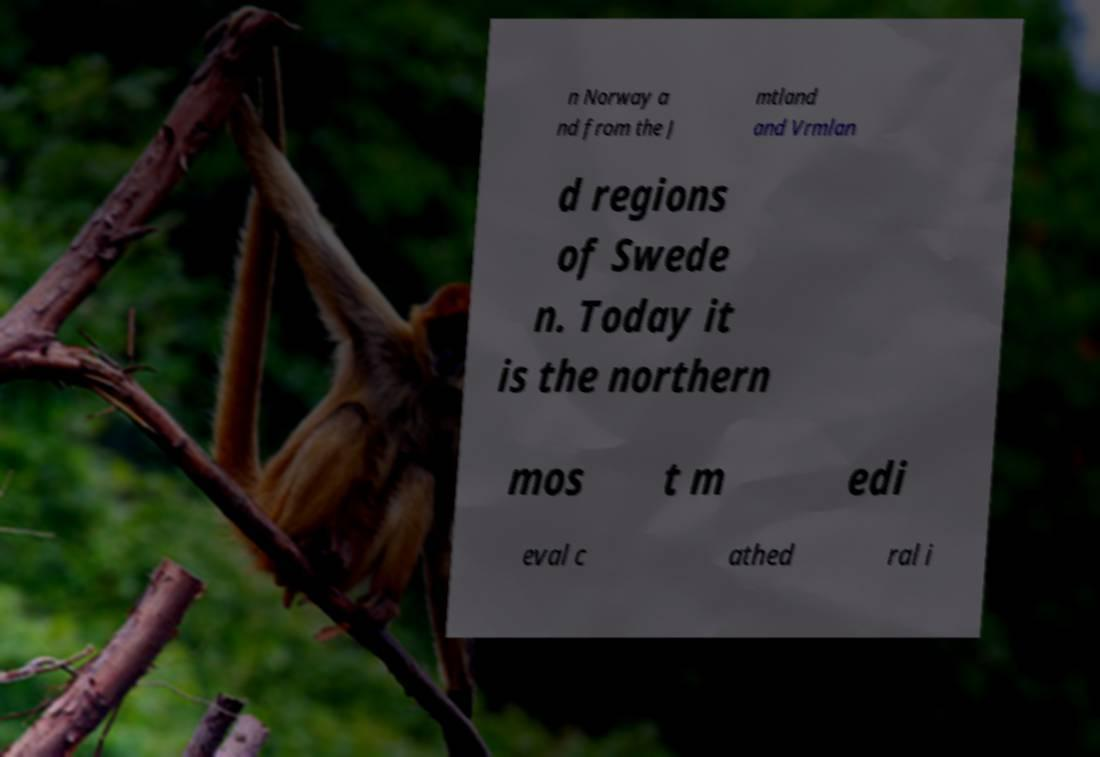Please identify and transcribe the text found in this image. n Norway a nd from the J mtland and Vrmlan d regions of Swede n. Today it is the northern mos t m edi eval c athed ral i 